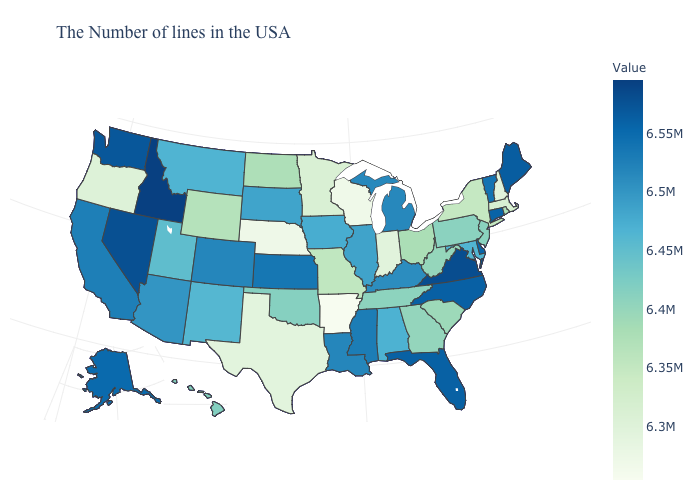Among the states that border Georgia , which have the lowest value?
Keep it brief. South Carolina. Is the legend a continuous bar?
Give a very brief answer. Yes. Does Nebraska have a higher value than Mississippi?
Short answer required. No. 